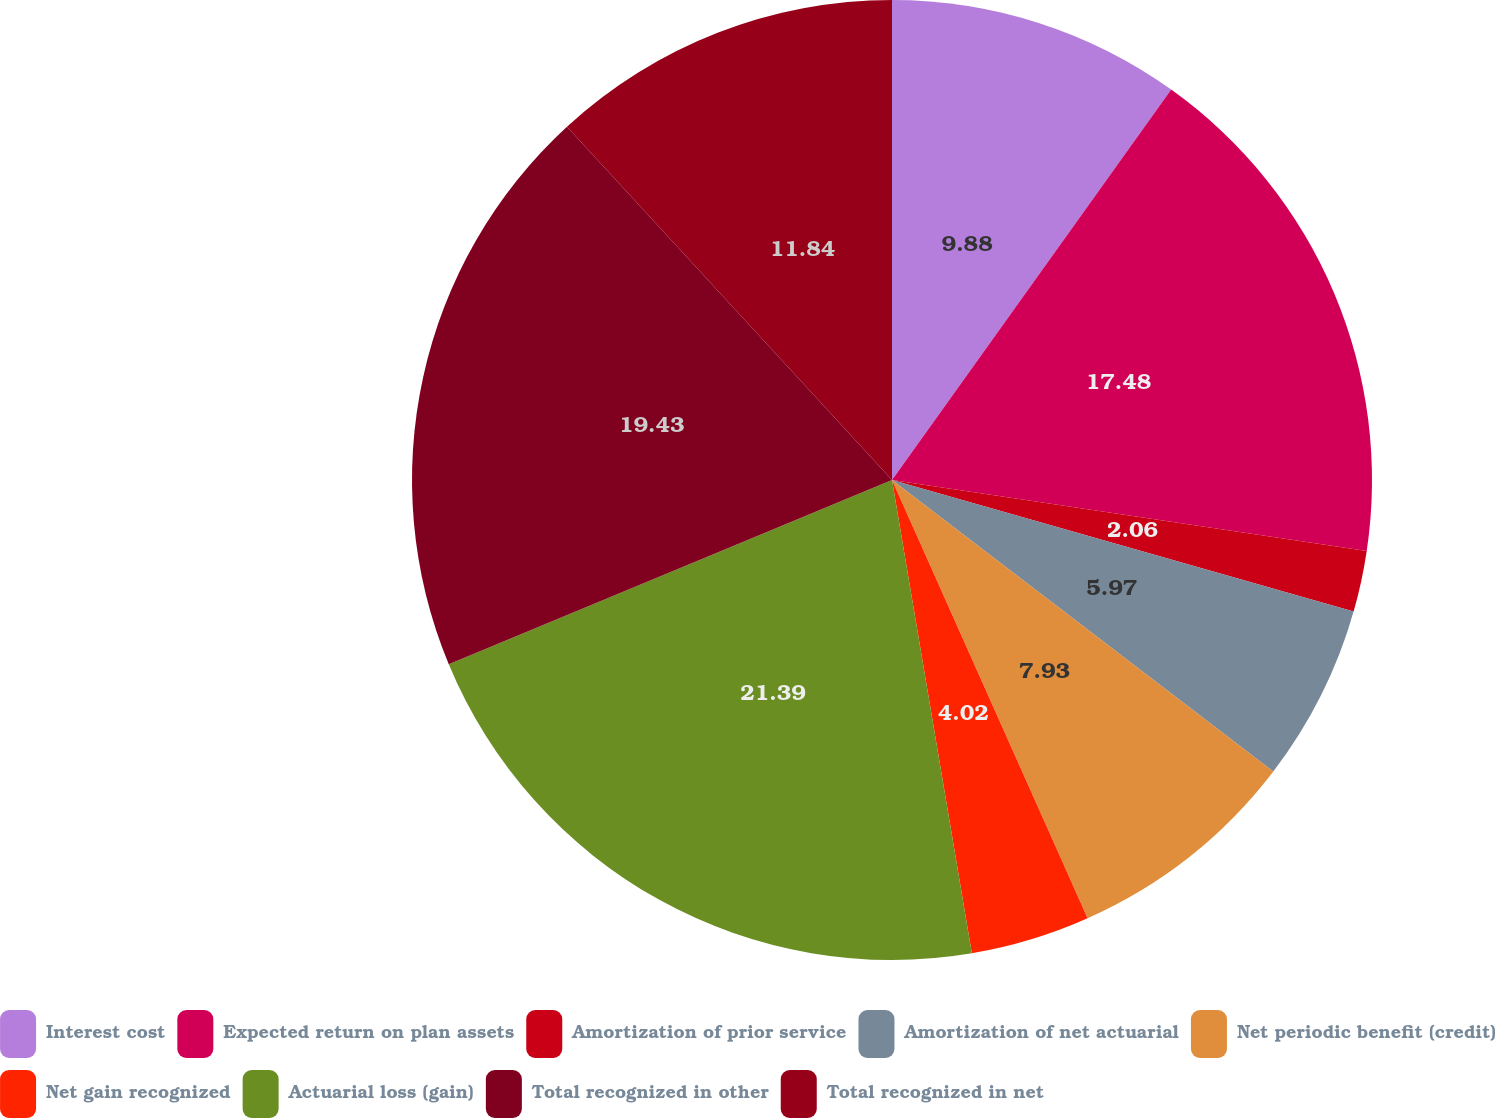<chart> <loc_0><loc_0><loc_500><loc_500><pie_chart><fcel>Interest cost<fcel>Expected return on plan assets<fcel>Amortization of prior service<fcel>Amortization of net actuarial<fcel>Net periodic benefit (credit)<fcel>Net gain recognized<fcel>Actuarial loss (gain)<fcel>Total recognized in other<fcel>Total recognized in net<nl><fcel>9.88%<fcel>17.48%<fcel>2.06%<fcel>5.97%<fcel>7.93%<fcel>4.02%<fcel>21.39%<fcel>19.43%<fcel>11.84%<nl></chart> 